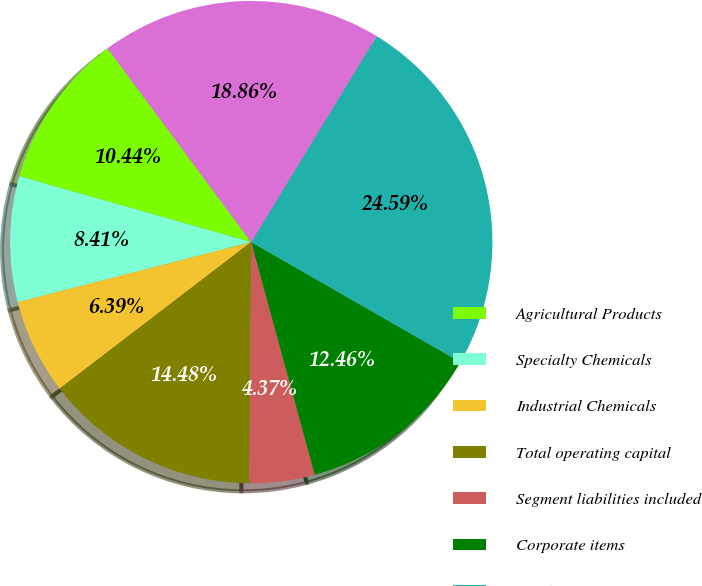<chart> <loc_0><loc_0><loc_500><loc_500><pie_chart><fcel>Agricultural Products<fcel>Specialty Chemicals<fcel>Industrial Chemicals<fcel>Total operating capital<fcel>Segment liabilities included<fcel>Corporate items<fcel>Total assets<fcel>Total segment assets<nl><fcel>10.44%<fcel>8.41%<fcel>6.39%<fcel>14.48%<fcel>4.37%<fcel>12.46%<fcel>24.59%<fcel>18.86%<nl></chart> 